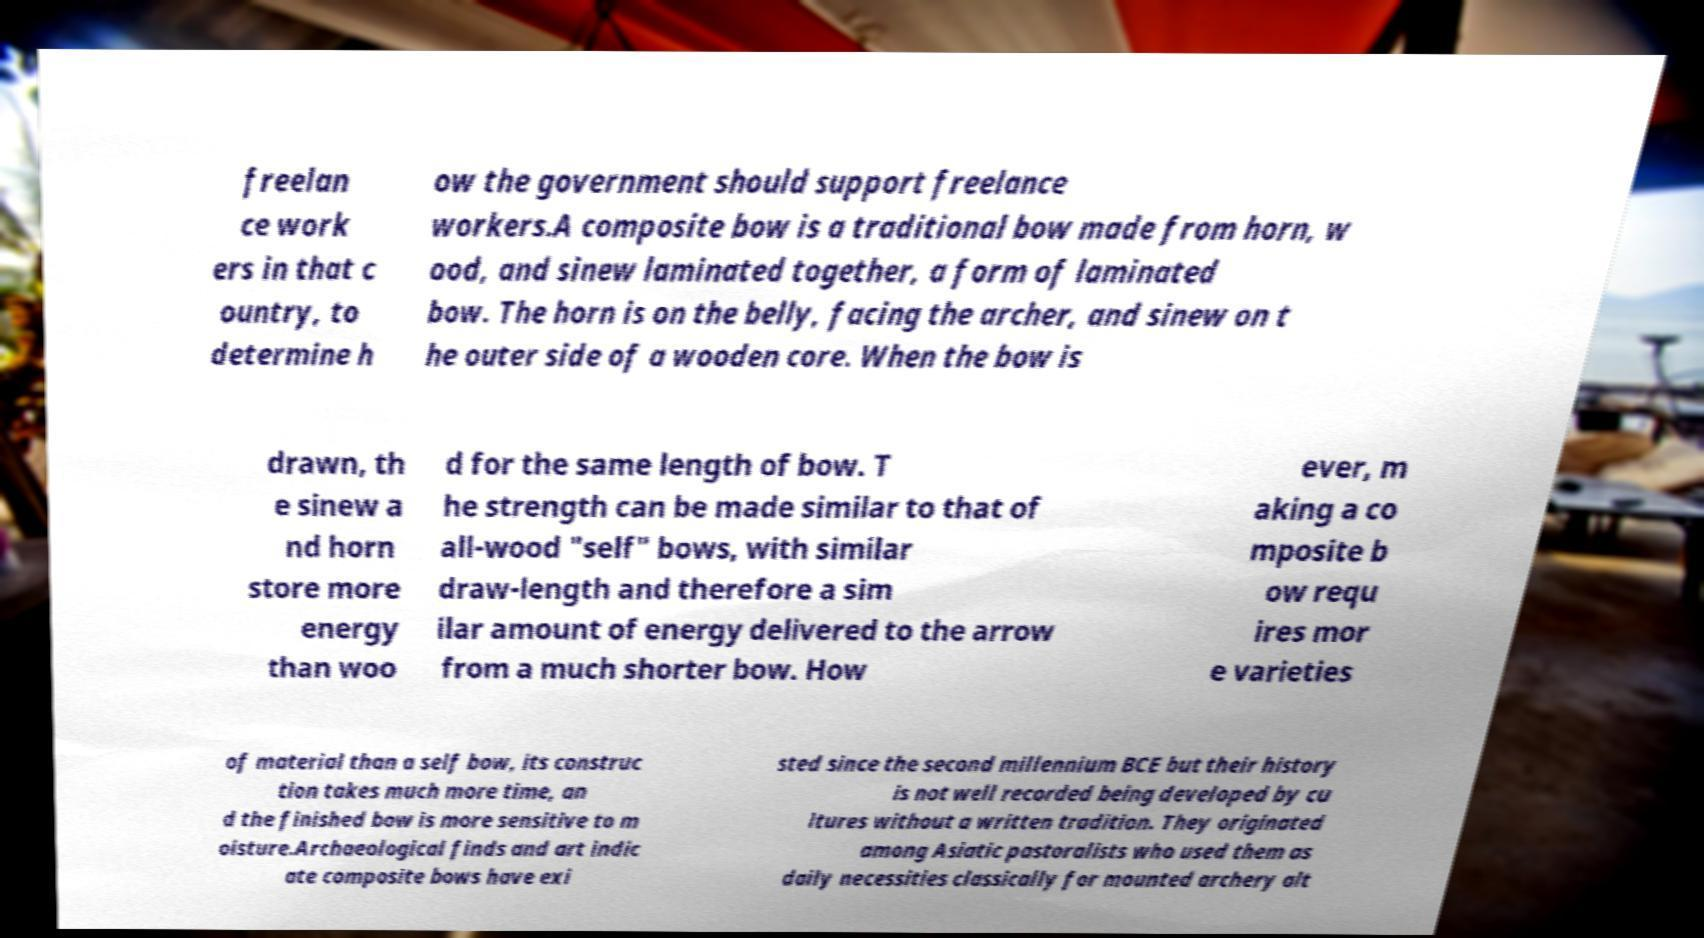Could you extract and type out the text from this image? freelan ce work ers in that c ountry, to determine h ow the government should support freelance workers.A composite bow is a traditional bow made from horn, w ood, and sinew laminated together, a form of laminated bow. The horn is on the belly, facing the archer, and sinew on t he outer side of a wooden core. When the bow is drawn, th e sinew a nd horn store more energy than woo d for the same length of bow. T he strength can be made similar to that of all-wood "self" bows, with similar draw-length and therefore a sim ilar amount of energy delivered to the arrow from a much shorter bow. How ever, m aking a co mposite b ow requ ires mor e varieties of material than a self bow, its construc tion takes much more time, an d the finished bow is more sensitive to m oisture.Archaeological finds and art indic ate composite bows have exi sted since the second millennium BCE but their history is not well recorded being developed by cu ltures without a written tradition. They originated among Asiatic pastoralists who used them as daily necessities classically for mounted archery alt 